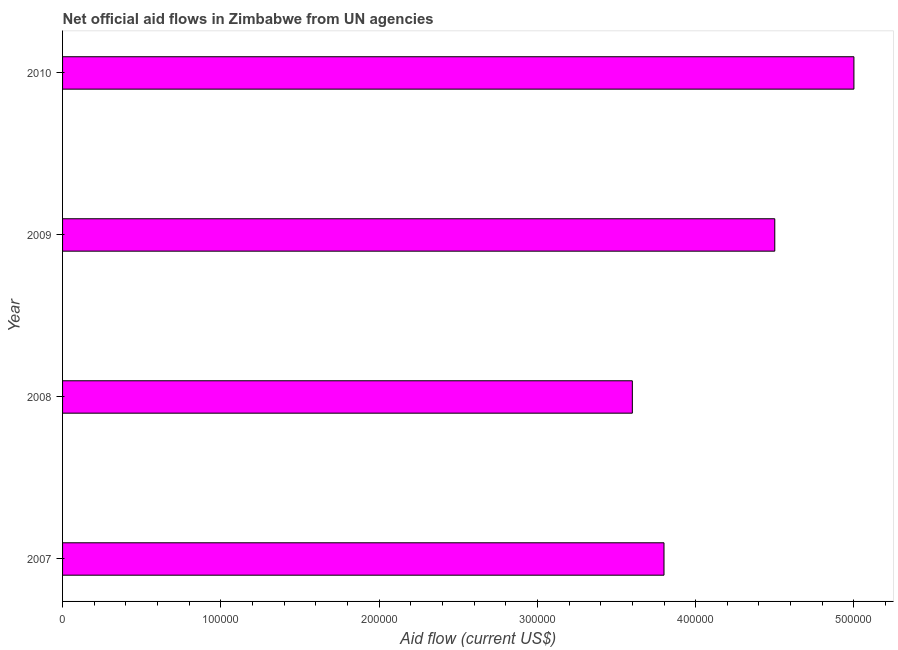Does the graph contain any zero values?
Keep it short and to the point. No. Does the graph contain grids?
Give a very brief answer. No. What is the title of the graph?
Your answer should be compact. Net official aid flows in Zimbabwe from UN agencies. Across all years, what is the minimum net official flows from un agencies?
Offer a very short reply. 3.60e+05. In which year was the net official flows from un agencies maximum?
Your answer should be very brief. 2010. What is the sum of the net official flows from un agencies?
Your answer should be very brief. 1.69e+06. What is the difference between the net official flows from un agencies in 2007 and 2010?
Offer a terse response. -1.20e+05. What is the average net official flows from un agencies per year?
Provide a short and direct response. 4.22e+05. What is the median net official flows from un agencies?
Keep it short and to the point. 4.15e+05. Do a majority of the years between 2008 and 2010 (inclusive) have net official flows from un agencies greater than 300000 US$?
Ensure brevity in your answer.  Yes. What is the ratio of the net official flows from un agencies in 2007 to that in 2009?
Offer a terse response. 0.84. What is the difference between the highest and the lowest net official flows from un agencies?
Your answer should be very brief. 1.40e+05. Are all the bars in the graph horizontal?
Your answer should be compact. Yes. How many years are there in the graph?
Your response must be concise. 4. Are the values on the major ticks of X-axis written in scientific E-notation?
Your answer should be compact. No. What is the Aid flow (current US$) in 2009?
Make the answer very short. 4.50e+05. What is the Aid flow (current US$) in 2010?
Offer a very short reply. 5.00e+05. What is the difference between the Aid flow (current US$) in 2007 and 2008?
Make the answer very short. 2.00e+04. What is the difference between the Aid flow (current US$) in 2007 and 2010?
Keep it short and to the point. -1.20e+05. What is the difference between the Aid flow (current US$) in 2008 and 2009?
Your answer should be very brief. -9.00e+04. What is the difference between the Aid flow (current US$) in 2008 and 2010?
Your answer should be compact. -1.40e+05. What is the ratio of the Aid flow (current US$) in 2007 to that in 2008?
Offer a very short reply. 1.06. What is the ratio of the Aid flow (current US$) in 2007 to that in 2009?
Make the answer very short. 0.84. What is the ratio of the Aid flow (current US$) in 2007 to that in 2010?
Your response must be concise. 0.76. What is the ratio of the Aid flow (current US$) in 2008 to that in 2009?
Your answer should be compact. 0.8. What is the ratio of the Aid flow (current US$) in 2008 to that in 2010?
Provide a short and direct response. 0.72. 